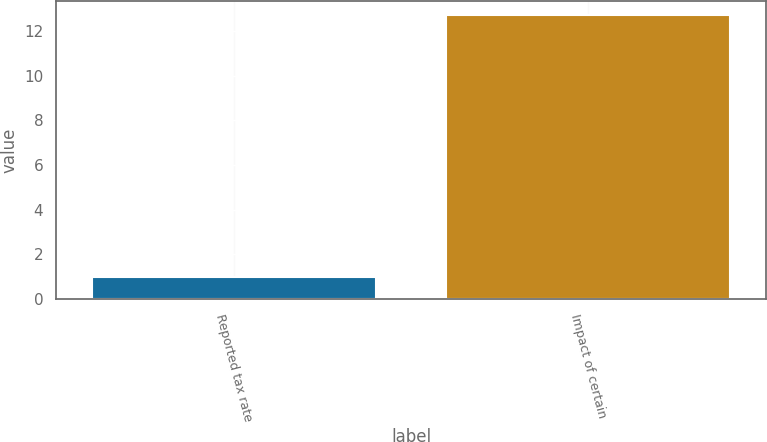<chart> <loc_0><loc_0><loc_500><loc_500><bar_chart><fcel>Reported tax rate<fcel>Impact of certain<nl><fcel>1<fcel>12.7<nl></chart> 